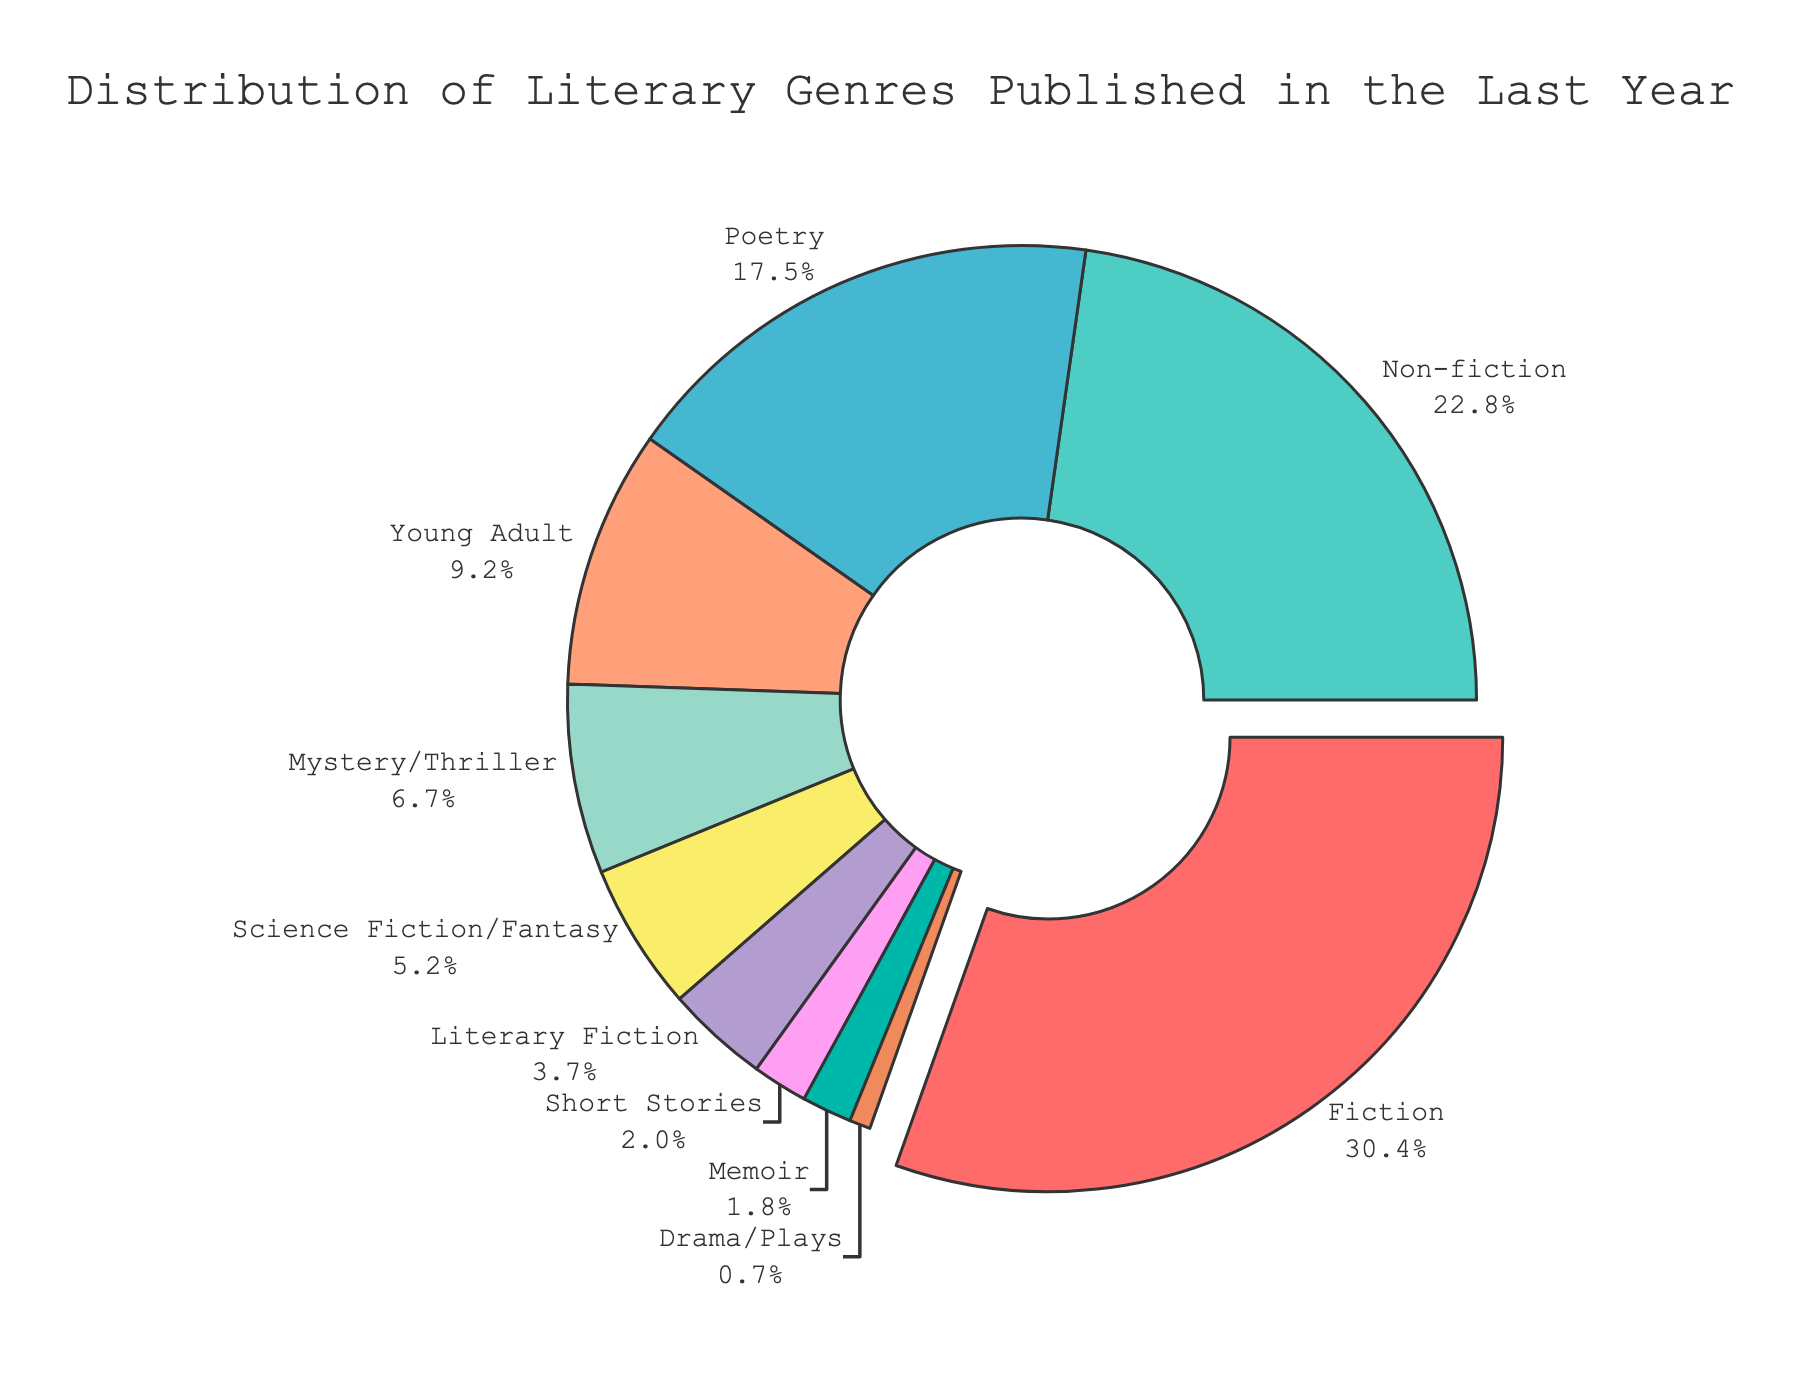Which genre has the highest percentage of publications? The genre with the highest percentage is the largest segment in the pie chart and is slightly pulled out from the center. By looking at the labels, we see that Fiction has the highest percentage of 32.5%.
Answer: Fiction What percentage do Fiction and Non-fiction together represent? To find the total percentage represented by Fiction and Non-fiction, we add their individual percentages: Fiction (32.5%) + Non-fiction (24.3%) = 56.8%.
Answer: 56.8% Which genres have a percentage less than 5%? Genres with percentages less than 5% are the smaller segments of the pie chart. They include Science Fiction/Fantasy (5.6%), Literary Fiction (3.9%), Short Stories (2.1%), Memoir (1.9%), and Drama/Plays (0.8%). However, Science Fiction/Fantasy (5.6%) is slightly above 5%. Removing it leaves Literary Fiction, Short Stories, Memoir, and Drama/Plays.
Answer: Literary Fiction, Short Stories, Memoir, Drama/Plays Which genre has the lowest percentage of publications? The genre with the lowest percentage is the smallest segment in the pie chart. Drama/Plays represents the smallest segment with 0.8%.
Answer: Drama/Plays Is the percentage of Young Adult publications more than double the percentage of Science Fiction/Fantasy? We compare Young Adult (9.8%) to Science Fiction/Fantasy (5.6%). First, doubling the Science Fiction/Fantasy percentage: 5.6% * 2 = 11.2%. Since 9.8% is less than 11.2%, Young Adult is not more than double Science Fiction/Fantasy.
Answer: No What is the combined percentage of Poetry and Memoir categories? We add the percentages of Poetry (18.7%) and Memoir (1.9%): 18.7% + 1.9% = 20.6%.
Answer: 20.6% How much larger is the Fiction segment compared to Mystery/Thriller? To find how much larger Fiction is compared to Mystery/Thriller, subtract Mystery/Thriller's percentage from Fiction's percentage: 32.5% - 7.2% = 25.3%.
Answer: 25.3% Which genre represents the second highest percentage of publications? The second largest segment in the pie chart is Poetry with 18.7%, just below Fiction (32.5%).
Answer: Poetry What is the total percentage of publications for the top three genres? Adding the percentages of the top three genres: Fiction (32.5%), Poetry (18.7%), and Non-fiction (24.3%), we get 32.5% + 18.7% + 24.3% = 75.5%.
Answer: 75.5% 